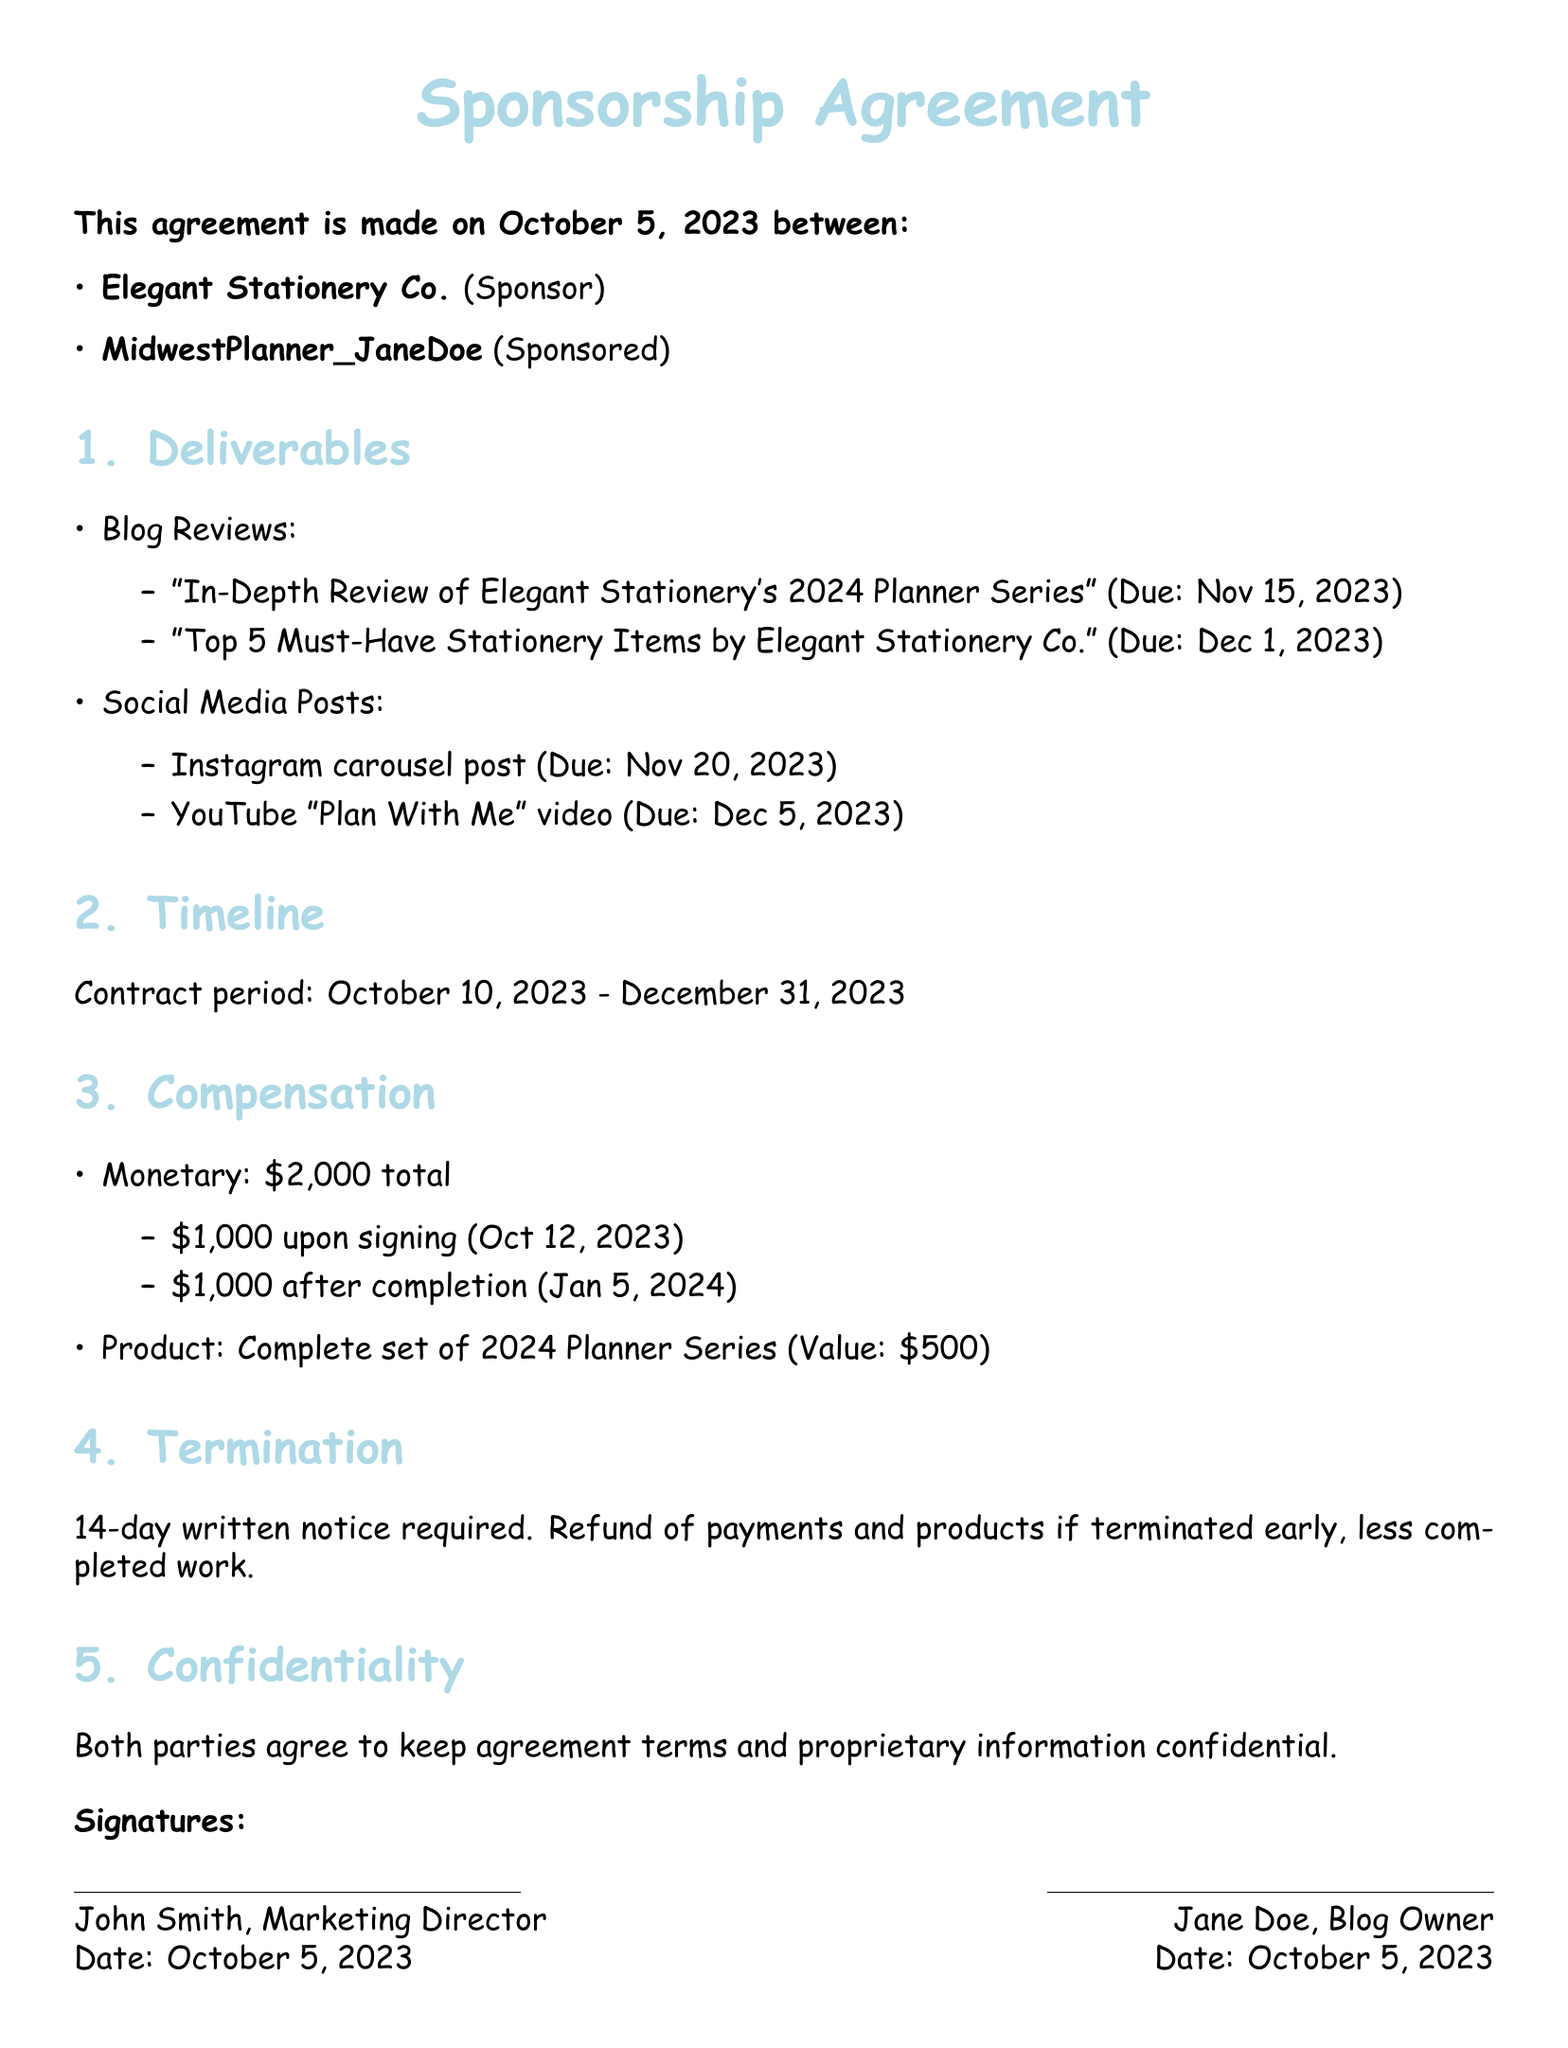What is the date of the agreement? The date of the agreement is explicitly stated in the document.
Answer: October 5, 2023 Who is the sponsor? The sponsor's name is clearly mentioned in the agreement.
Answer: Elegant Stationery Co What are the due dates for the blog reviews? The document outlines two specific due dates for blog reviews, which can be found in the deliverables section.
Answer: November 15, 2023 and December 1, 2023 How much is the total compensation? The total compensation amount is aggregated in the compensation section of the document.
Answer: $2,000 When will the final payment be made? The payment timeline specifies when the final payment will be issued after completion.
Answer: January 5, 2024 What is the value of the product compensation? The document provides the value of the product given as compensation, which is stated in the compensation section.
Answer: $500 How long is the contract period? The contract period is explicitly stated in the timeline section of the document.
Answer: October 10, 2023 - December 31, 2023 How many days' notice is required for termination? The termination section specifies the required notice duration.
Answer: 14-day What type of posts are included in the sponsorship? The deliverables section identifies the types of posts included in the sponsorship agreement.
Answer: Blog Reviews and Social Media Posts What is required in case of early termination? The termination section outlines the requirements and consequences of terminating the agreement early.
Answer: Refund of payments and products if terminated early, less completed work 